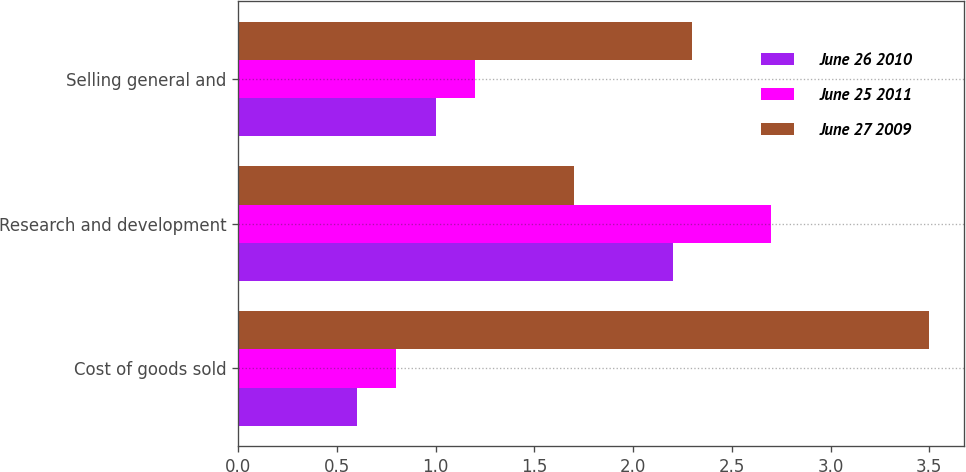<chart> <loc_0><loc_0><loc_500><loc_500><stacked_bar_chart><ecel><fcel>Cost of goods sold<fcel>Research and development<fcel>Selling general and<nl><fcel>June 26 2010<fcel>0.6<fcel>2.2<fcel>1<nl><fcel>June 25 2011<fcel>0.8<fcel>2.7<fcel>1.2<nl><fcel>June 27 2009<fcel>3.5<fcel>1.7<fcel>2.3<nl></chart> 